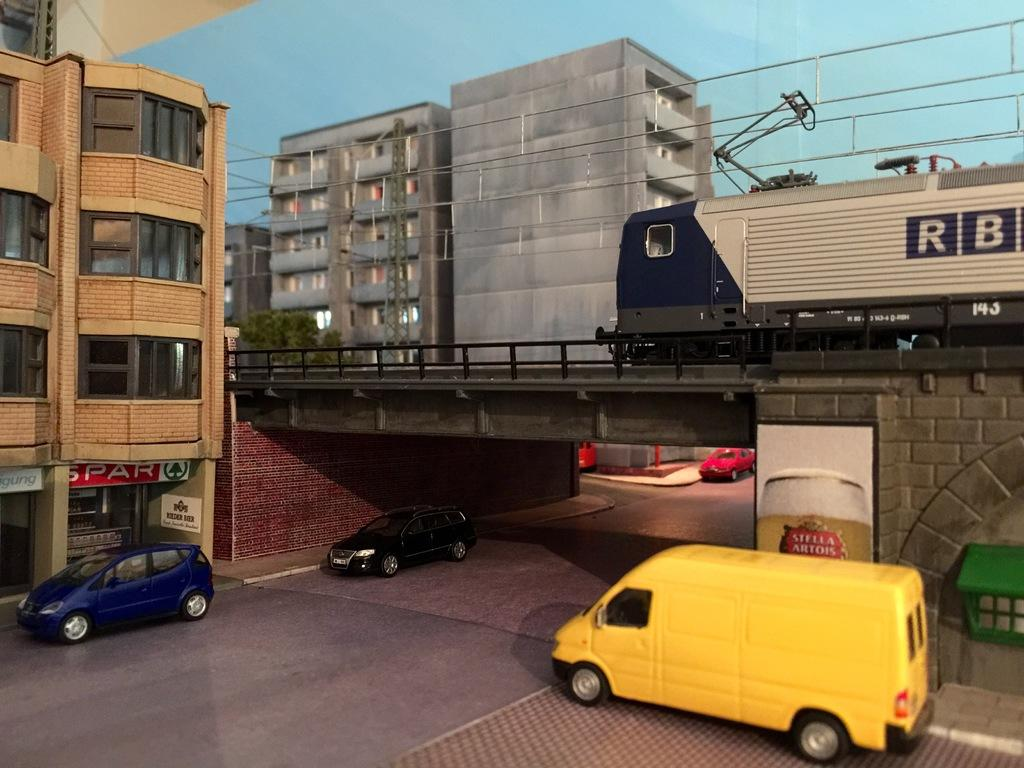What can be seen on the road in the image? There are vehicles on the road in the image. What type of structures are visible in the image? There are buildings with windows in the image. What is the tower in the image used for? The tower in the image has wires, suggesting it might be a communication tower. What type of vegetation is present in the image? There are plants in the image. What mode of transportation can be seen on a bridge in the image? There is a train on a bridge in the image. How would you describe the sky in the image? The sky is visible in the image and appears cloudy. Are there any dinosaurs visible in the image? No, there are no dinosaurs present in the image. What type of lace can be seen on the buildings in the image? There is no lace visible on the buildings in the image. 